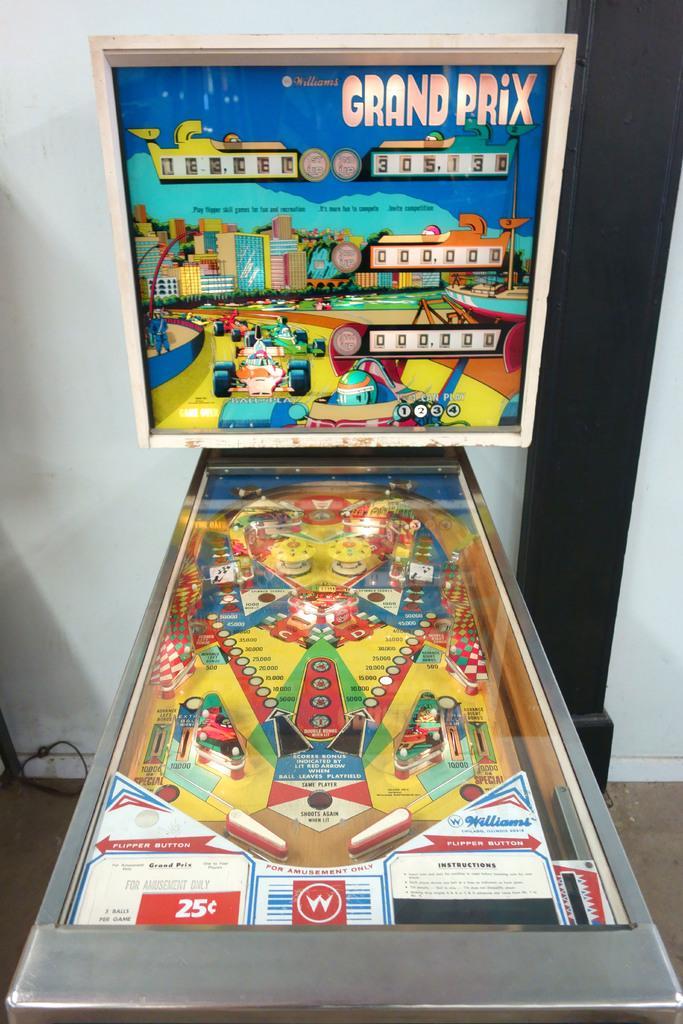Could you give a brief overview of what you see in this image? We can see game boards and posters. We can see floor, wall and pillar. 